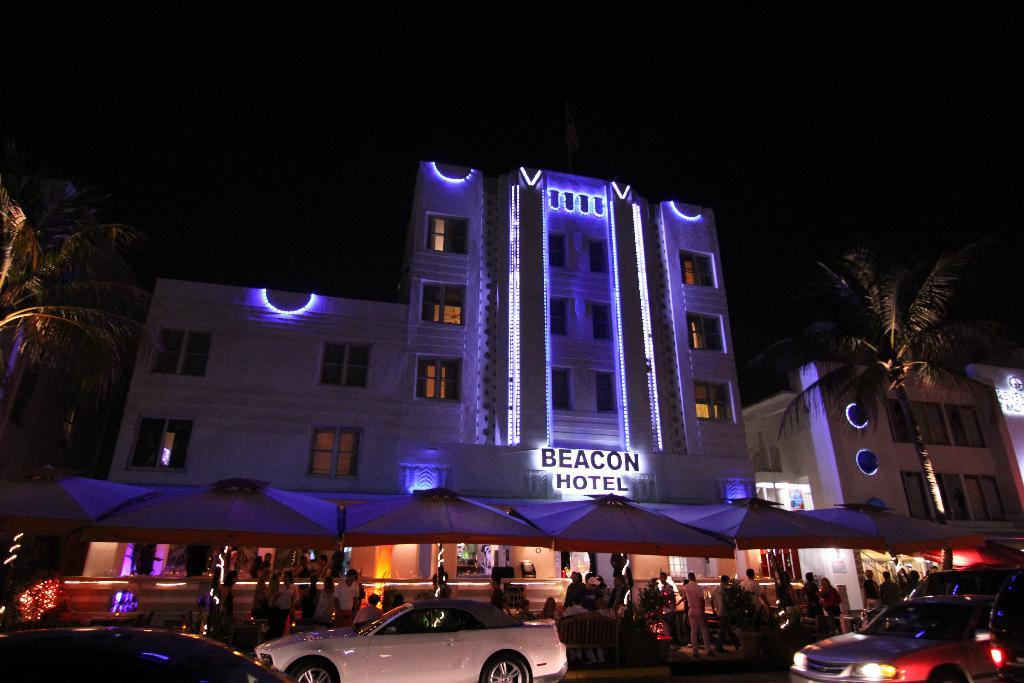What type of structures can be seen in the image? There are buildings in the image. What can be seen illuminating the scene in the image? There are lights in the image. What type of temporary shelters are present in the image? There are tents in the image. Can you describe the people in the image? There are people in the image. What mode of transportation is visible in the image? There are vehicles in the image. What type of seating is available in the image? There are benches in the image. What type of natural elements are present in the image? There are trees in the image. How would you describe the sky in the image? The sky is dark in the image. What else can be seen in the image besides the mentioned elements? There are objects in the image. What type of spoon is being used to cut the trees in the image? There is no spoon present in the image, nor are any trees being cut. How many pairs of scissors can be seen in the image? There are no scissors present in the image. 